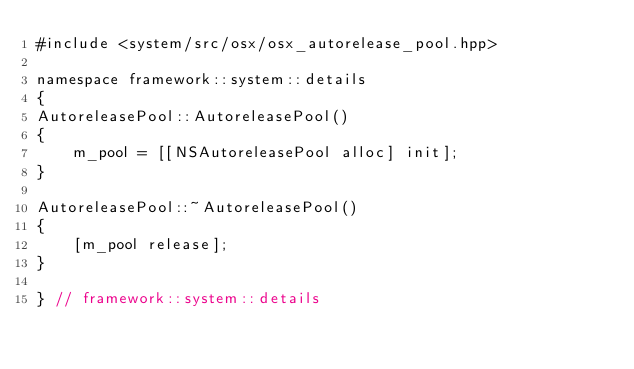<code> <loc_0><loc_0><loc_500><loc_500><_ObjectiveC_>#include <system/src/osx/osx_autorelease_pool.hpp>

namespace framework::system::details
{
AutoreleasePool::AutoreleasePool()
{
    m_pool = [[NSAutoreleasePool alloc] init];
}

AutoreleasePool::~AutoreleasePool()
{
    [m_pool release];
}

} // framework::system::details
</code> 